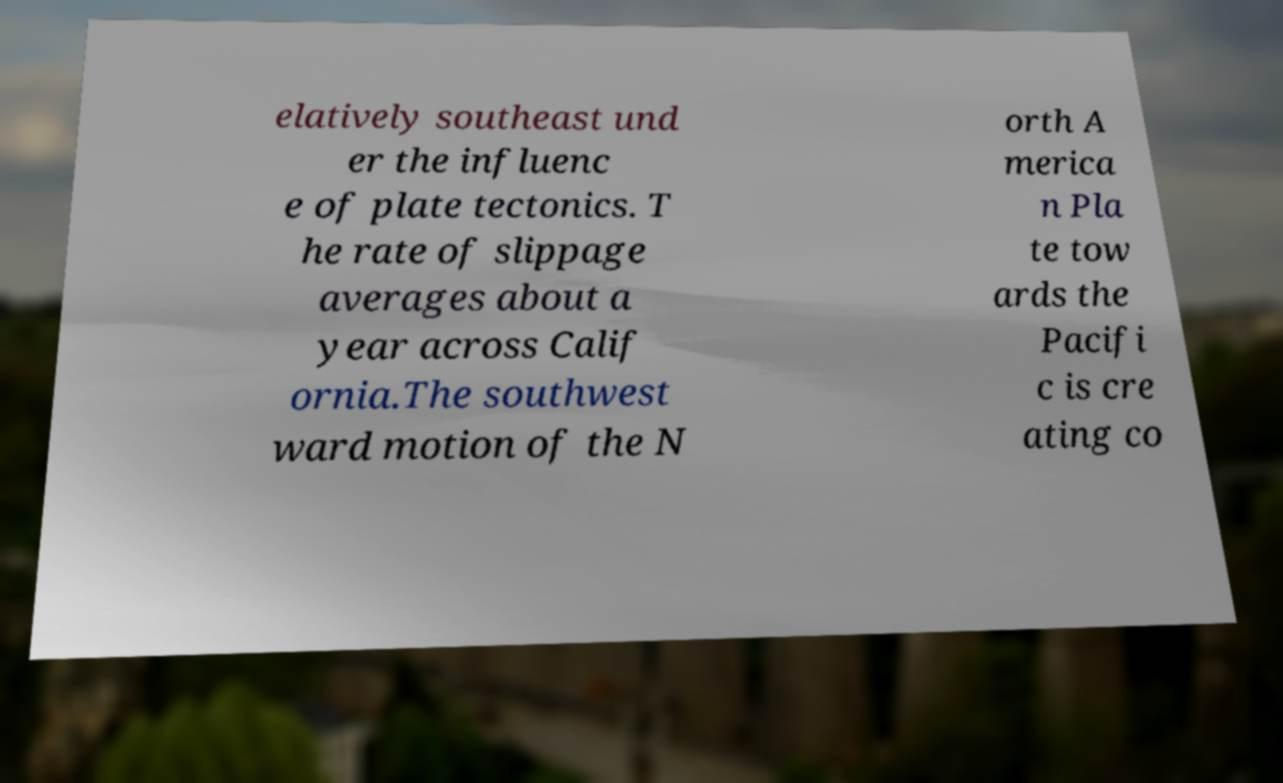There's text embedded in this image that I need extracted. Can you transcribe it verbatim? elatively southeast und er the influenc e of plate tectonics. T he rate of slippage averages about a year across Calif ornia.The southwest ward motion of the N orth A merica n Pla te tow ards the Pacifi c is cre ating co 